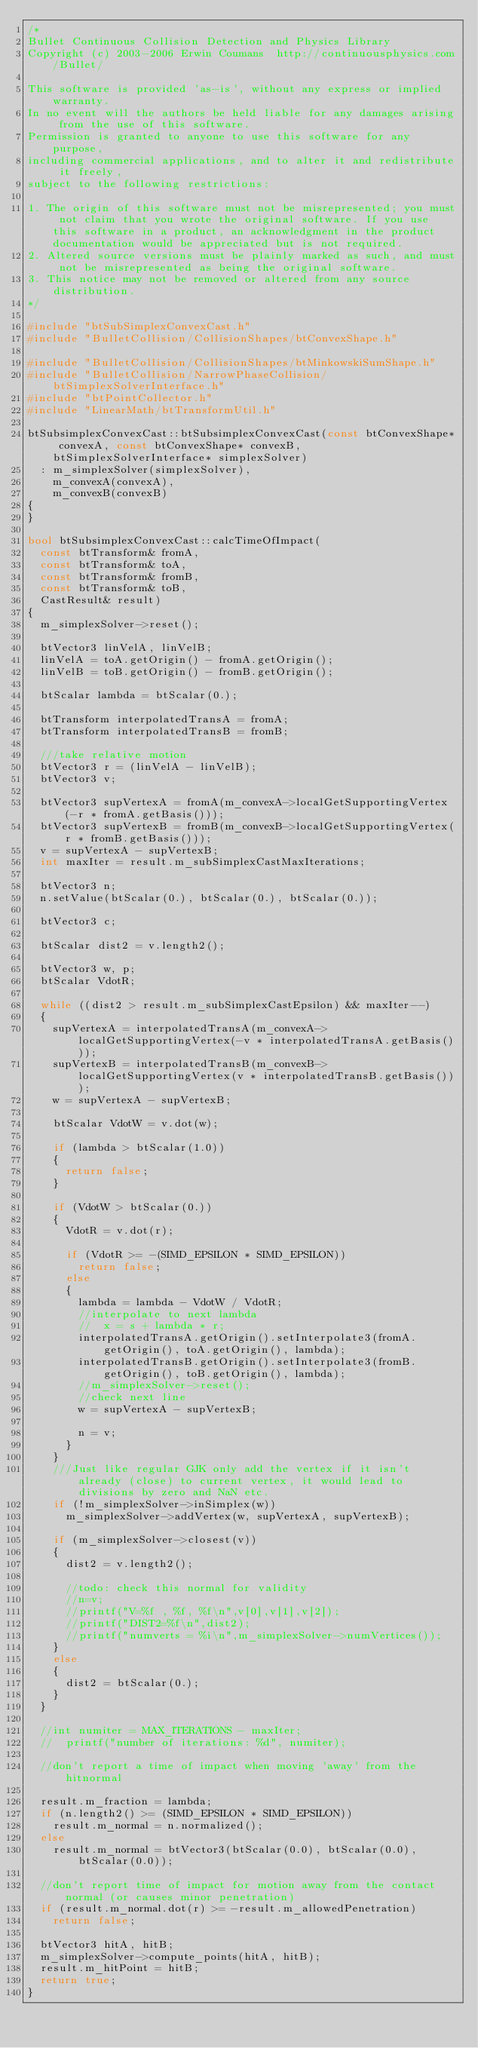<code> <loc_0><loc_0><loc_500><loc_500><_C++_>/*
Bullet Continuous Collision Detection and Physics Library
Copyright (c) 2003-2006 Erwin Coumans  http://continuousphysics.com/Bullet/

This software is provided 'as-is', without any express or implied warranty.
In no event will the authors be held liable for any damages arising from the use of this software.
Permission is granted to anyone to use this software for any purpose, 
including commercial applications, and to alter it and redistribute it freely, 
subject to the following restrictions:

1. The origin of this software must not be misrepresented; you must not claim that you wrote the original software. If you use this software in a product, an acknowledgment in the product documentation would be appreciated but is not required.
2. Altered source versions must be plainly marked as such, and must not be misrepresented as being the original software.
3. This notice may not be removed or altered from any source distribution.
*/

#include "btSubSimplexConvexCast.h"
#include "BulletCollision/CollisionShapes/btConvexShape.h"

#include "BulletCollision/CollisionShapes/btMinkowskiSumShape.h"
#include "BulletCollision/NarrowPhaseCollision/btSimplexSolverInterface.h"
#include "btPointCollector.h"
#include "LinearMath/btTransformUtil.h"

btSubsimplexConvexCast::btSubsimplexConvexCast(const btConvexShape* convexA, const btConvexShape* convexB, btSimplexSolverInterface* simplexSolver)
	: m_simplexSolver(simplexSolver),
	  m_convexA(convexA),
	  m_convexB(convexB)
{
}

bool btSubsimplexConvexCast::calcTimeOfImpact(
	const btTransform& fromA,
	const btTransform& toA,
	const btTransform& fromB,
	const btTransform& toB,
	CastResult& result)
{
	m_simplexSolver->reset();

	btVector3 linVelA, linVelB;
	linVelA = toA.getOrigin() - fromA.getOrigin();
	linVelB = toB.getOrigin() - fromB.getOrigin();

	btScalar lambda = btScalar(0.);

	btTransform interpolatedTransA = fromA;
	btTransform interpolatedTransB = fromB;

	///take relative motion
	btVector3 r = (linVelA - linVelB);
	btVector3 v;

	btVector3 supVertexA = fromA(m_convexA->localGetSupportingVertex(-r * fromA.getBasis()));
	btVector3 supVertexB = fromB(m_convexB->localGetSupportingVertex(r * fromB.getBasis()));
	v = supVertexA - supVertexB;
	int maxIter = result.m_subSimplexCastMaxIterations;

	btVector3 n;
	n.setValue(btScalar(0.), btScalar(0.), btScalar(0.));

	btVector3 c;

	btScalar dist2 = v.length2();

	btVector3 w, p;
	btScalar VdotR;

	while ((dist2 > result.m_subSimplexCastEpsilon) && maxIter--)
	{
		supVertexA = interpolatedTransA(m_convexA->localGetSupportingVertex(-v * interpolatedTransA.getBasis()));
		supVertexB = interpolatedTransB(m_convexB->localGetSupportingVertex(v * interpolatedTransB.getBasis()));
		w = supVertexA - supVertexB;

		btScalar VdotW = v.dot(w);

		if (lambda > btScalar(1.0))
		{
			return false;
		}

		if (VdotW > btScalar(0.))
		{
			VdotR = v.dot(r);

			if (VdotR >= -(SIMD_EPSILON * SIMD_EPSILON))
				return false;
			else
			{
				lambda = lambda - VdotW / VdotR;
				//interpolate to next lambda
				//	x = s + lambda * r;
				interpolatedTransA.getOrigin().setInterpolate3(fromA.getOrigin(), toA.getOrigin(), lambda);
				interpolatedTransB.getOrigin().setInterpolate3(fromB.getOrigin(), toB.getOrigin(), lambda);
				//m_simplexSolver->reset();
				//check next line
				w = supVertexA - supVertexB;

				n = v;
			}
		}
		///Just like regular GJK only add the vertex if it isn't already (close) to current vertex, it would lead to divisions by zero and NaN etc.
		if (!m_simplexSolver->inSimplex(w))
			m_simplexSolver->addVertex(w, supVertexA, supVertexB);

		if (m_simplexSolver->closest(v))
		{
			dist2 = v.length2();

			//todo: check this normal for validity
			//n=v;
			//printf("V=%f , %f, %f\n",v[0],v[1],v[2]);
			//printf("DIST2=%f\n",dist2);
			//printf("numverts = %i\n",m_simplexSolver->numVertices());
		}
		else
		{
			dist2 = btScalar(0.);
		}
	}

	//int numiter = MAX_ITERATIONS - maxIter;
	//	printf("number of iterations: %d", numiter);

	//don't report a time of impact when moving 'away' from the hitnormal

	result.m_fraction = lambda;
	if (n.length2() >= (SIMD_EPSILON * SIMD_EPSILON))
		result.m_normal = n.normalized();
	else
		result.m_normal = btVector3(btScalar(0.0), btScalar(0.0), btScalar(0.0));

	//don't report time of impact for motion away from the contact normal (or causes minor penetration)
	if (result.m_normal.dot(r) >= -result.m_allowedPenetration)
		return false;

	btVector3 hitA, hitB;
	m_simplexSolver->compute_points(hitA, hitB);
	result.m_hitPoint = hitB;
	return true;
}
</code> 